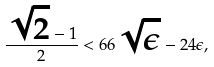<formula> <loc_0><loc_0><loc_500><loc_500>\frac { \sqrt { 2 } - 1 } { 2 } < 6 6 \sqrt { \epsilon } - 2 4 \epsilon ,</formula> 